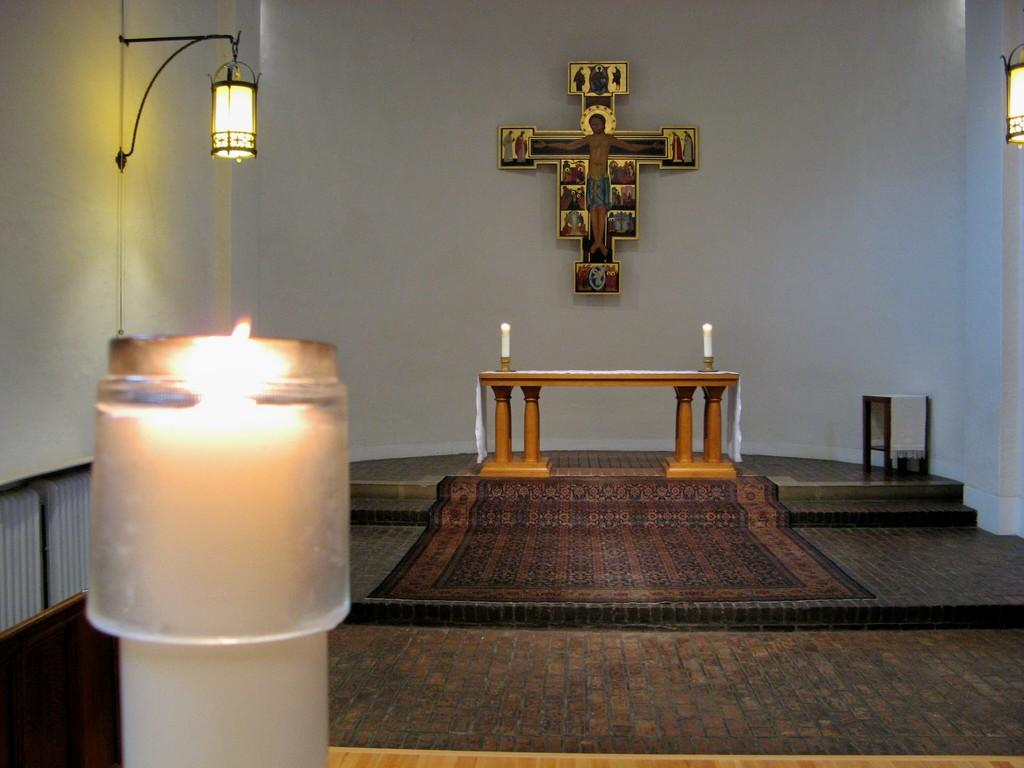What object is located on the left side of the image? There is a candle on the left side of the image. Where is the candle placed? The candle is on a table. What type of light source is visible in the image? There is a light in the image. How many candles are in the middle of the image? There are two candles in the middle of the image. What is present in the image that might hold a picture or artwork? There is a frame in the image. What type of architectural feature is visible in the image? There is a wall in the image. What type of reaction can be seen in the image? There is no reaction visible in the image; it is a still design. What sign is present in the image? There is no sign present in the image. 